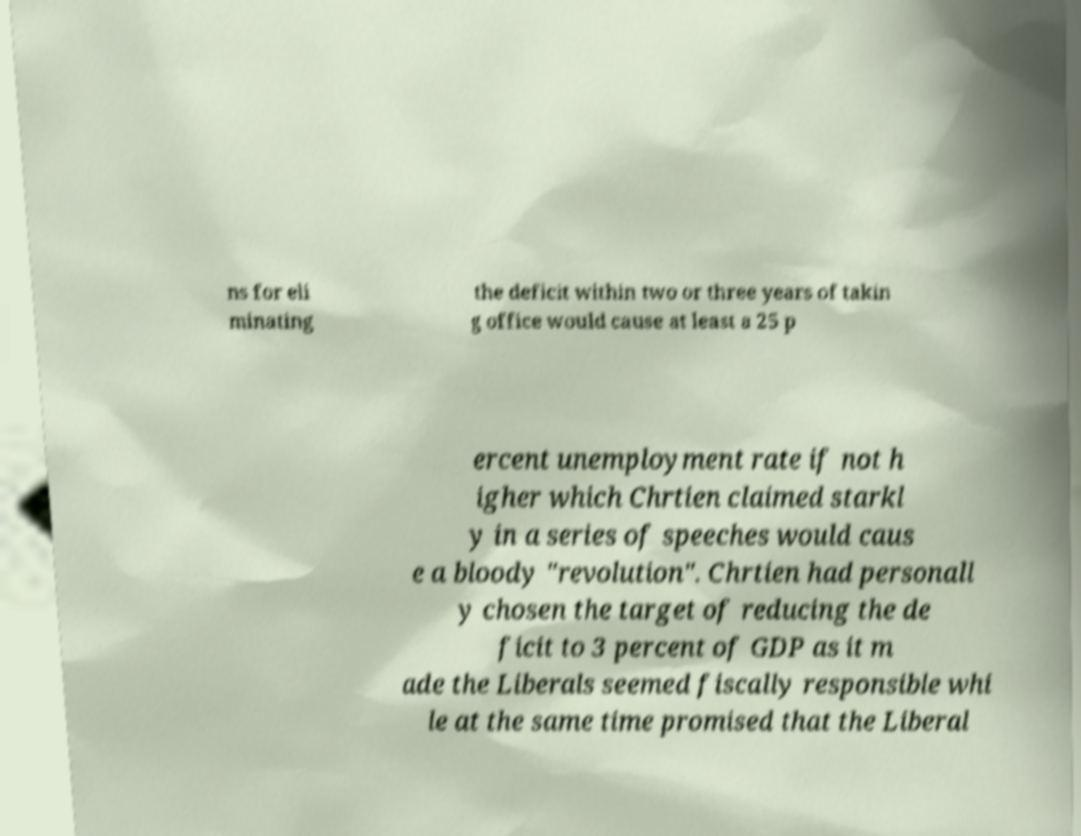There's text embedded in this image that I need extracted. Can you transcribe it verbatim? ns for eli minating the deficit within two or three years of takin g office would cause at least a 25 p ercent unemployment rate if not h igher which Chrtien claimed starkl y in a series of speeches would caus e a bloody "revolution". Chrtien had personall y chosen the target of reducing the de ficit to 3 percent of GDP as it m ade the Liberals seemed fiscally responsible whi le at the same time promised that the Liberal 